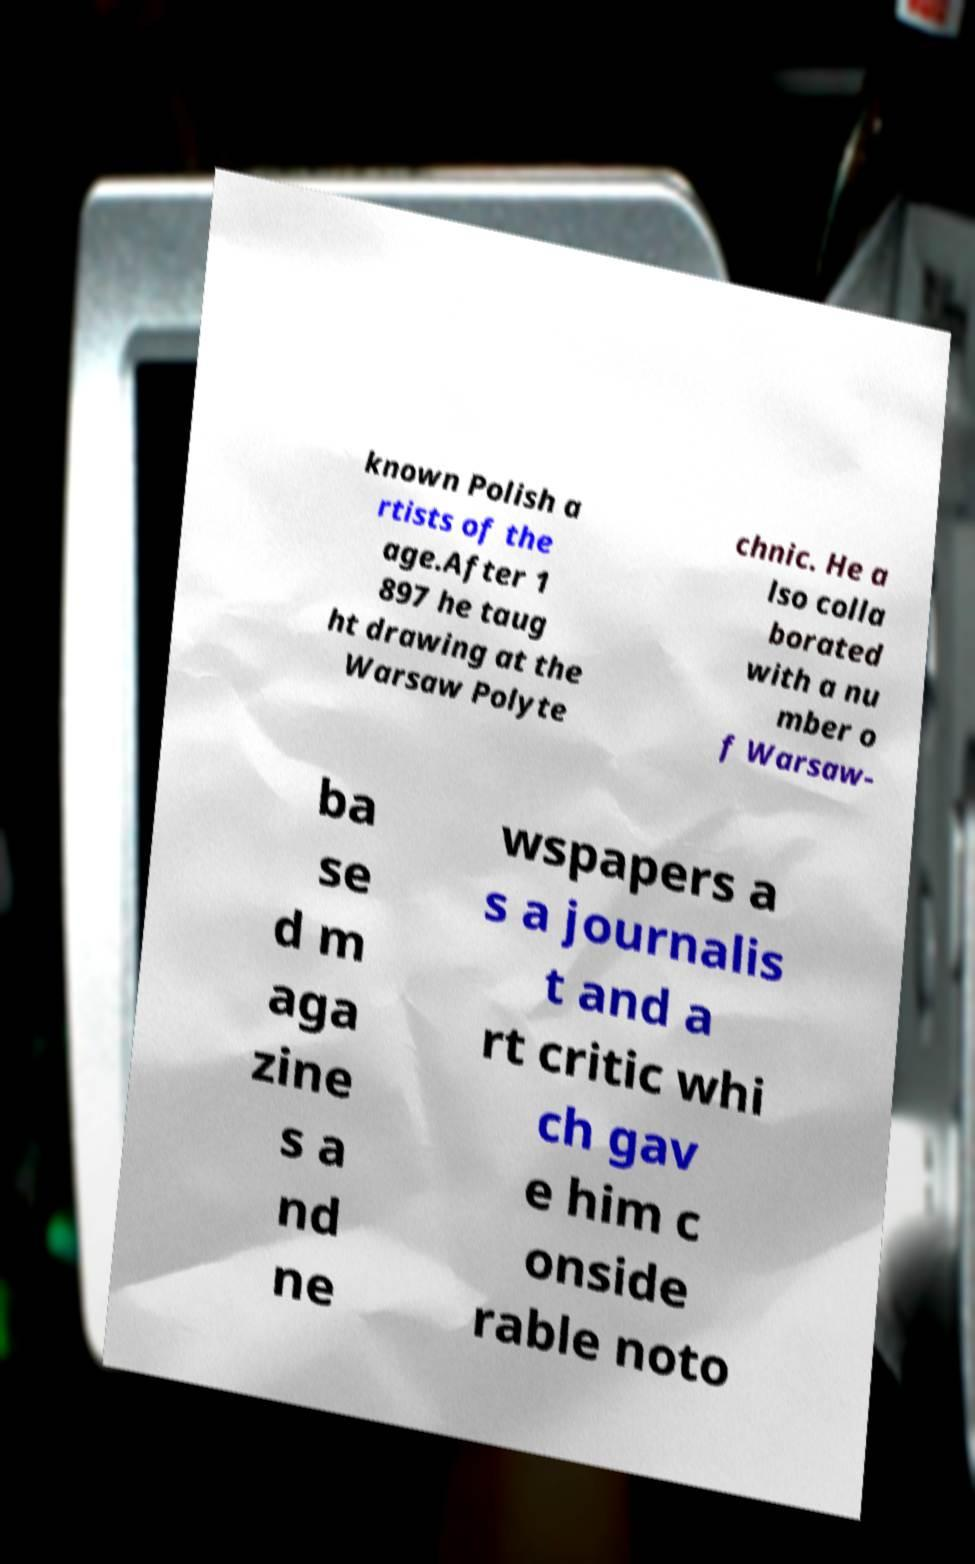Could you assist in decoding the text presented in this image and type it out clearly? known Polish a rtists of the age.After 1 897 he taug ht drawing at the Warsaw Polyte chnic. He a lso colla borated with a nu mber o f Warsaw- ba se d m aga zine s a nd ne wspapers a s a journalis t and a rt critic whi ch gav e him c onside rable noto 